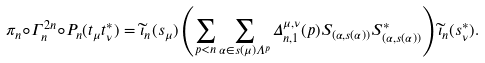Convert formula to latex. <formula><loc_0><loc_0><loc_500><loc_500>\pi _ { n } \circ \Gamma ^ { 2 n } _ { n } \circ P _ { n } ( t _ { \mu } t ^ { * } _ { \nu } ) = \widetilde { \iota } _ { n } ( s _ { \mu } ) \left ( \sum _ { p < n } \sum _ { \alpha \in s ( \mu ) \Lambda ^ { p } } \Delta _ { n , 1 } ^ { \mu , \nu } ( p ) S _ { ( \alpha , s ( \alpha ) ) } S _ { ( \alpha , s ( \alpha ) ) } ^ { * } \right ) \widetilde { \iota } _ { n } ( s _ { \nu } ^ { * } ) .</formula> 